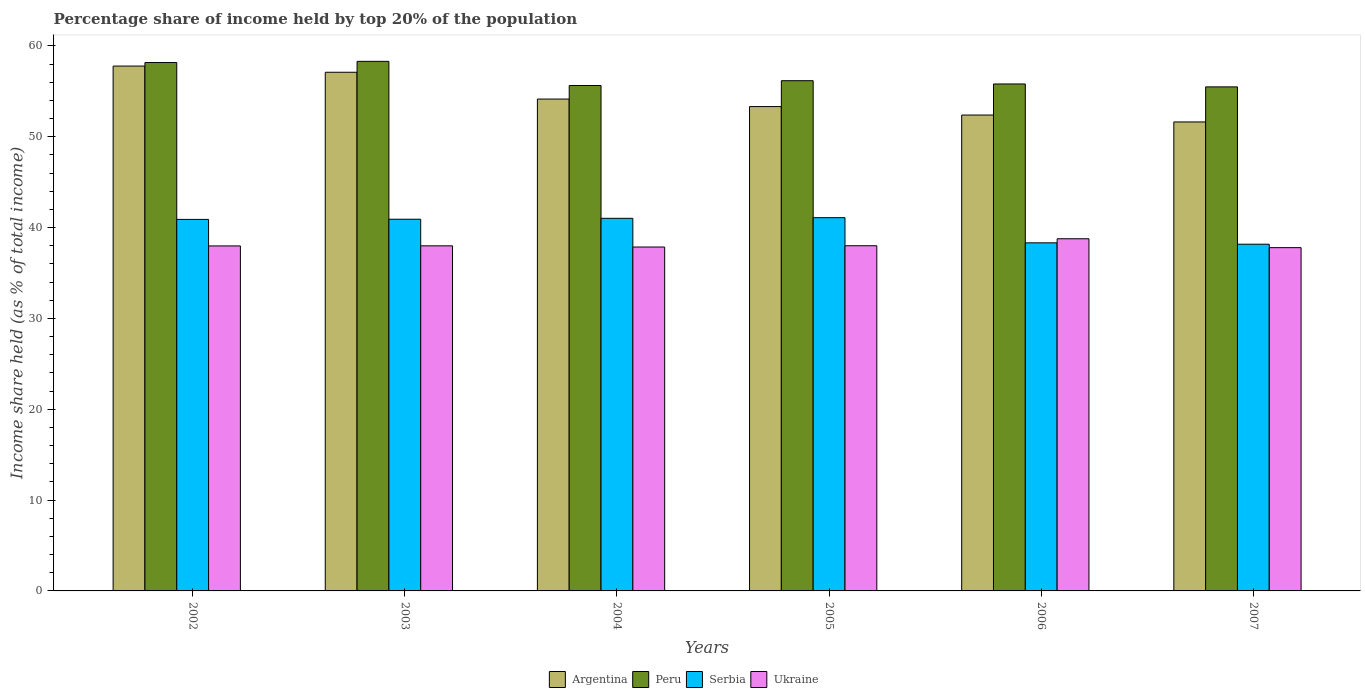How many different coloured bars are there?
Provide a succinct answer. 4. Are the number of bars on each tick of the X-axis equal?
Provide a short and direct response. Yes. How many bars are there on the 5th tick from the right?
Give a very brief answer. 4. What is the label of the 4th group of bars from the left?
Your answer should be compact. 2005. In how many cases, is the number of bars for a given year not equal to the number of legend labels?
Keep it short and to the point. 0. What is the percentage share of income held by top 20% of the population in Peru in 2006?
Make the answer very short. 55.81. Across all years, what is the maximum percentage share of income held by top 20% of the population in Ukraine?
Keep it short and to the point. 38.77. Across all years, what is the minimum percentage share of income held by top 20% of the population in Serbia?
Provide a succinct answer. 38.17. In which year was the percentage share of income held by top 20% of the population in Peru maximum?
Make the answer very short. 2003. In which year was the percentage share of income held by top 20% of the population in Serbia minimum?
Ensure brevity in your answer.  2007. What is the total percentage share of income held by top 20% of the population in Argentina in the graph?
Make the answer very short. 326.37. What is the difference between the percentage share of income held by top 20% of the population in Serbia in 2003 and that in 2005?
Your response must be concise. -0.17. What is the difference between the percentage share of income held by top 20% of the population in Serbia in 2005 and the percentage share of income held by top 20% of the population in Peru in 2004?
Provide a short and direct response. -14.55. What is the average percentage share of income held by top 20% of the population in Peru per year?
Give a very brief answer. 56.6. In the year 2006, what is the difference between the percentage share of income held by top 20% of the population in Serbia and percentage share of income held by top 20% of the population in Peru?
Your answer should be very brief. -17.49. What is the ratio of the percentage share of income held by top 20% of the population in Serbia in 2004 to that in 2007?
Provide a short and direct response. 1.07. Is the difference between the percentage share of income held by top 20% of the population in Serbia in 2002 and 2006 greater than the difference between the percentage share of income held by top 20% of the population in Peru in 2002 and 2006?
Provide a short and direct response. Yes. What is the difference between the highest and the second highest percentage share of income held by top 20% of the population in Argentina?
Offer a terse response. 0.68. What is the difference between the highest and the lowest percentage share of income held by top 20% of the population in Peru?
Ensure brevity in your answer.  2.81. In how many years, is the percentage share of income held by top 20% of the population in Serbia greater than the average percentage share of income held by top 20% of the population in Serbia taken over all years?
Keep it short and to the point. 4. Is the sum of the percentage share of income held by top 20% of the population in Ukraine in 2002 and 2005 greater than the maximum percentage share of income held by top 20% of the population in Argentina across all years?
Provide a short and direct response. Yes. What does the 2nd bar from the left in 2002 represents?
Your answer should be very brief. Peru. What does the 2nd bar from the right in 2007 represents?
Offer a terse response. Serbia. Is it the case that in every year, the sum of the percentage share of income held by top 20% of the population in Peru and percentage share of income held by top 20% of the population in Ukraine is greater than the percentage share of income held by top 20% of the population in Argentina?
Ensure brevity in your answer.  Yes. How many bars are there?
Your answer should be compact. 24. Are all the bars in the graph horizontal?
Give a very brief answer. No. Are the values on the major ticks of Y-axis written in scientific E-notation?
Offer a very short reply. No. What is the title of the graph?
Give a very brief answer. Percentage share of income held by top 20% of the population. What is the label or title of the Y-axis?
Provide a succinct answer. Income share held (as % of total income). What is the Income share held (as % of total income) of Argentina in 2002?
Your response must be concise. 57.78. What is the Income share held (as % of total income) in Peru in 2002?
Offer a very short reply. 58.17. What is the Income share held (as % of total income) in Serbia in 2002?
Your answer should be compact. 40.9. What is the Income share held (as % of total income) of Ukraine in 2002?
Provide a short and direct response. 37.98. What is the Income share held (as % of total income) in Argentina in 2003?
Make the answer very short. 57.1. What is the Income share held (as % of total income) of Peru in 2003?
Offer a very short reply. 58.3. What is the Income share held (as % of total income) in Serbia in 2003?
Make the answer very short. 40.92. What is the Income share held (as % of total income) in Ukraine in 2003?
Ensure brevity in your answer.  37.99. What is the Income share held (as % of total income) in Argentina in 2004?
Give a very brief answer. 54.15. What is the Income share held (as % of total income) of Peru in 2004?
Your answer should be compact. 55.64. What is the Income share held (as % of total income) in Serbia in 2004?
Your answer should be very brief. 41.02. What is the Income share held (as % of total income) of Ukraine in 2004?
Your answer should be compact. 37.86. What is the Income share held (as % of total income) in Argentina in 2005?
Offer a terse response. 53.32. What is the Income share held (as % of total income) of Peru in 2005?
Offer a very short reply. 56.17. What is the Income share held (as % of total income) in Serbia in 2005?
Give a very brief answer. 41.09. What is the Income share held (as % of total income) of Argentina in 2006?
Keep it short and to the point. 52.39. What is the Income share held (as % of total income) of Peru in 2006?
Offer a very short reply. 55.81. What is the Income share held (as % of total income) of Serbia in 2006?
Provide a short and direct response. 38.32. What is the Income share held (as % of total income) of Ukraine in 2006?
Make the answer very short. 38.77. What is the Income share held (as % of total income) of Argentina in 2007?
Offer a terse response. 51.63. What is the Income share held (as % of total income) of Peru in 2007?
Your answer should be compact. 55.49. What is the Income share held (as % of total income) of Serbia in 2007?
Offer a very short reply. 38.17. What is the Income share held (as % of total income) in Ukraine in 2007?
Your response must be concise. 37.79. Across all years, what is the maximum Income share held (as % of total income) of Argentina?
Provide a short and direct response. 57.78. Across all years, what is the maximum Income share held (as % of total income) of Peru?
Provide a short and direct response. 58.3. Across all years, what is the maximum Income share held (as % of total income) in Serbia?
Make the answer very short. 41.09. Across all years, what is the maximum Income share held (as % of total income) in Ukraine?
Offer a terse response. 38.77. Across all years, what is the minimum Income share held (as % of total income) in Argentina?
Offer a terse response. 51.63. Across all years, what is the minimum Income share held (as % of total income) of Peru?
Your answer should be compact. 55.49. Across all years, what is the minimum Income share held (as % of total income) in Serbia?
Your answer should be compact. 38.17. Across all years, what is the minimum Income share held (as % of total income) of Ukraine?
Ensure brevity in your answer.  37.79. What is the total Income share held (as % of total income) in Argentina in the graph?
Keep it short and to the point. 326.37. What is the total Income share held (as % of total income) in Peru in the graph?
Offer a very short reply. 339.58. What is the total Income share held (as % of total income) of Serbia in the graph?
Your answer should be very brief. 240.42. What is the total Income share held (as % of total income) of Ukraine in the graph?
Your answer should be very brief. 228.39. What is the difference between the Income share held (as % of total income) of Argentina in 2002 and that in 2003?
Offer a very short reply. 0.68. What is the difference between the Income share held (as % of total income) in Peru in 2002 and that in 2003?
Give a very brief answer. -0.13. What is the difference between the Income share held (as % of total income) in Serbia in 2002 and that in 2003?
Your response must be concise. -0.02. What is the difference between the Income share held (as % of total income) of Ukraine in 2002 and that in 2003?
Your answer should be compact. -0.01. What is the difference between the Income share held (as % of total income) in Argentina in 2002 and that in 2004?
Your answer should be very brief. 3.63. What is the difference between the Income share held (as % of total income) in Peru in 2002 and that in 2004?
Keep it short and to the point. 2.53. What is the difference between the Income share held (as % of total income) of Serbia in 2002 and that in 2004?
Provide a short and direct response. -0.12. What is the difference between the Income share held (as % of total income) in Ukraine in 2002 and that in 2004?
Offer a very short reply. 0.12. What is the difference between the Income share held (as % of total income) in Argentina in 2002 and that in 2005?
Give a very brief answer. 4.46. What is the difference between the Income share held (as % of total income) of Peru in 2002 and that in 2005?
Offer a terse response. 2. What is the difference between the Income share held (as % of total income) of Serbia in 2002 and that in 2005?
Your response must be concise. -0.19. What is the difference between the Income share held (as % of total income) of Ukraine in 2002 and that in 2005?
Your response must be concise. -0.02. What is the difference between the Income share held (as % of total income) in Argentina in 2002 and that in 2006?
Provide a short and direct response. 5.39. What is the difference between the Income share held (as % of total income) of Peru in 2002 and that in 2006?
Your response must be concise. 2.36. What is the difference between the Income share held (as % of total income) in Serbia in 2002 and that in 2006?
Offer a very short reply. 2.58. What is the difference between the Income share held (as % of total income) of Ukraine in 2002 and that in 2006?
Your answer should be compact. -0.79. What is the difference between the Income share held (as % of total income) in Argentina in 2002 and that in 2007?
Make the answer very short. 6.15. What is the difference between the Income share held (as % of total income) in Peru in 2002 and that in 2007?
Your answer should be compact. 2.68. What is the difference between the Income share held (as % of total income) in Serbia in 2002 and that in 2007?
Your response must be concise. 2.73. What is the difference between the Income share held (as % of total income) of Ukraine in 2002 and that in 2007?
Keep it short and to the point. 0.19. What is the difference between the Income share held (as % of total income) of Argentina in 2003 and that in 2004?
Keep it short and to the point. 2.95. What is the difference between the Income share held (as % of total income) of Peru in 2003 and that in 2004?
Offer a very short reply. 2.66. What is the difference between the Income share held (as % of total income) of Serbia in 2003 and that in 2004?
Your answer should be compact. -0.1. What is the difference between the Income share held (as % of total income) in Ukraine in 2003 and that in 2004?
Ensure brevity in your answer.  0.13. What is the difference between the Income share held (as % of total income) of Argentina in 2003 and that in 2005?
Make the answer very short. 3.78. What is the difference between the Income share held (as % of total income) in Peru in 2003 and that in 2005?
Provide a short and direct response. 2.13. What is the difference between the Income share held (as % of total income) in Serbia in 2003 and that in 2005?
Make the answer very short. -0.17. What is the difference between the Income share held (as % of total income) of Ukraine in 2003 and that in 2005?
Keep it short and to the point. -0.01. What is the difference between the Income share held (as % of total income) of Argentina in 2003 and that in 2006?
Give a very brief answer. 4.71. What is the difference between the Income share held (as % of total income) in Peru in 2003 and that in 2006?
Keep it short and to the point. 2.49. What is the difference between the Income share held (as % of total income) of Ukraine in 2003 and that in 2006?
Your answer should be very brief. -0.78. What is the difference between the Income share held (as % of total income) of Argentina in 2003 and that in 2007?
Provide a short and direct response. 5.47. What is the difference between the Income share held (as % of total income) in Peru in 2003 and that in 2007?
Offer a terse response. 2.81. What is the difference between the Income share held (as % of total income) of Serbia in 2003 and that in 2007?
Your answer should be compact. 2.75. What is the difference between the Income share held (as % of total income) in Ukraine in 2003 and that in 2007?
Provide a succinct answer. 0.2. What is the difference between the Income share held (as % of total income) of Argentina in 2004 and that in 2005?
Ensure brevity in your answer.  0.83. What is the difference between the Income share held (as % of total income) of Peru in 2004 and that in 2005?
Give a very brief answer. -0.53. What is the difference between the Income share held (as % of total income) in Serbia in 2004 and that in 2005?
Keep it short and to the point. -0.07. What is the difference between the Income share held (as % of total income) of Ukraine in 2004 and that in 2005?
Your answer should be compact. -0.14. What is the difference between the Income share held (as % of total income) in Argentina in 2004 and that in 2006?
Your answer should be very brief. 1.76. What is the difference between the Income share held (as % of total income) in Peru in 2004 and that in 2006?
Keep it short and to the point. -0.17. What is the difference between the Income share held (as % of total income) of Ukraine in 2004 and that in 2006?
Make the answer very short. -0.91. What is the difference between the Income share held (as % of total income) of Argentina in 2004 and that in 2007?
Provide a succinct answer. 2.52. What is the difference between the Income share held (as % of total income) in Peru in 2004 and that in 2007?
Ensure brevity in your answer.  0.15. What is the difference between the Income share held (as % of total income) of Serbia in 2004 and that in 2007?
Provide a short and direct response. 2.85. What is the difference between the Income share held (as % of total income) of Ukraine in 2004 and that in 2007?
Ensure brevity in your answer.  0.07. What is the difference between the Income share held (as % of total income) of Argentina in 2005 and that in 2006?
Provide a succinct answer. 0.93. What is the difference between the Income share held (as % of total income) of Peru in 2005 and that in 2006?
Your response must be concise. 0.36. What is the difference between the Income share held (as % of total income) of Serbia in 2005 and that in 2006?
Give a very brief answer. 2.77. What is the difference between the Income share held (as % of total income) in Ukraine in 2005 and that in 2006?
Your answer should be very brief. -0.77. What is the difference between the Income share held (as % of total income) of Argentina in 2005 and that in 2007?
Offer a terse response. 1.69. What is the difference between the Income share held (as % of total income) in Peru in 2005 and that in 2007?
Your response must be concise. 0.68. What is the difference between the Income share held (as % of total income) in Serbia in 2005 and that in 2007?
Ensure brevity in your answer.  2.92. What is the difference between the Income share held (as % of total income) in Ukraine in 2005 and that in 2007?
Ensure brevity in your answer.  0.21. What is the difference between the Income share held (as % of total income) of Argentina in 2006 and that in 2007?
Provide a short and direct response. 0.76. What is the difference between the Income share held (as % of total income) in Peru in 2006 and that in 2007?
Provide a short and direct response. 0.32. What is the difference between the Income share held (as % of total income) of Serbia in 2006 and that in 2007?
Your answer should be very brief. 0.15. What is the difference between the Income share held (as % of total income) in Argentina in 2002 and the Income share held (as % of total income) in Peru in 2003?
Make the answer very short. -0.52. What is the difference between the Income share held (as % of total income) of Argentina in 2002 and the Income share held (as % of total income) of Serbia in 2003?
Your response must be concise. 16.86. What is the difference between the Income share held (as % of total income) of Argentina in 2002 and the Income share held (as % of total income) of Ukraine in 2003?
Your answer should be very brief. 19.79. What is the difference between the Income share held (as % of total income) in Peru in 2002 and the Income share held (as % of total income) in Serbia in 2003?
Keep it short and to the point. 17.25. What is the difference between the Income share held (as % of total income) in Peru in 2002 and the Income share held (as % of total income) in Ukraine in 2003?
Offer a terse response. 20.18. What is the difference between the Income share held (as % of total income) of Serbia in 2002 and the Income share held (as % of total income) of Ukraine in 2003?
Your answer should be compact. 2.91. What is the difference between the Income share held (as % of total income) in Argentina in 2002 and the Income share held (as % of total income) in Peru in 2004?
Provide a succinct answer. 2.14. What is the difference between the Income share held (as % of total income) in Argentina in 2002 and the Income share held (as % of total income) in Serbia in 2004?
Ensure brevity in your answer.  16.76. What is the difference between the Income share held (as % of total income) in Argentina in 2002 and the Income share held (as % of total income) in Ukraine in 2004?
Offer a very short reply. 19.92. What is the difference between the Income share held (as % of total income) of Peru in 2002 and the Income share held (as % of total income) of Serbia in 2004?
Your response must be concise. 17.15. What is the difference between the Income share held (as % of total income) of Peru in 2002 and the Income share held (as % of total income) of Ukraine in 2004?
Make the answer very short. 20.31. What is the difference between the Income share held (as % of total income) of Serbia in 2002 and the Income share held (as % of total income) of Ukraine in 2004?
Keep it short and to the point. 3.04. What is the difference between the Income share held (as % of total income) of Argentina in 2002 and the Income share held (as % of total income) of Peru in 2005?
Provide a short and direct response. 1.61. What is the difference between the Income share held (as % of total income) in Argentina in 2002 and the Income share held (as % of total income) in Serbia in 2005?
Provide a short and direct response. 16.69. What is the difference between the Income share held (as % of total income) of Argentina in 2002 and the Income share held (as % of total income) of Ukraine in 2005?
Offer a very short reply. 19.78. What is the difference between the Income share held (as % of total income) of Peru in 2002 and the Income share held (as % of total income) of Serbia in 2005?
Provide a succinct answer. 17.08. What is the difference between the Income share held (as % of total income) of Peru in 2002 and the Income share held (as % of total income) of Ukraine in 2005?
Offer a very short reply. 20.17. What is the difference between the Income share held (as % of total income) of Argentina in 2002 and the Income share held (as % of total income) of Peru in 2006?
Provide a succinct answer. 1.97. What is the difference between the Income share held (as % of total income) in Argentina in 2002 and the Income share held (as % of total income) in Serbia in 2006?
Provide a succinct answer. 19.46. What is the difference between the Income share held (as % of total income) of Argentina in 2002 and the Income share held (as % of total income) of Ukraine in 2006?
Your answer should be compact. 19.01. What is the difference between the Income share held (as % of total income) in Peru in 2002 and the Income share held (as % of total income) in Serbia in 2006?
Offer a terse response. 19.85. What is the difference between the Income share held (as % of total income) in Serbia in 2002 and the Income share held (as % of total income) in Ukraine in 2006?
Give a very brief answer. 2.13. What is the difference between the Income share held (as % of total income) of Argentina in 2002 and the Income share held (as % of total income) of Peru in 2007?
Your response must be concise. 2.29. What is the difference between the Income share held (as % of total income) in Argentina in 2002 and the Income share held (as % of total income) in Serbia in 2007?
Provide a succinct answer. 19.61. What is the difference between the Income share held (as % of total income) of Argentina in 2002 and the Income share held (as % of total income) of Ukraine in 2007?
Offer a terse response. 19.99. What is the difference between the Income share held (as % of total income) of Peru in 2002 and the Income share held (as % of total income) of Ukraine in 2007?
Provide a succinct answer. 20.38. What is the difference between the Income share held (as % of total income) of Serbia in 2002 and the Income share held (as % of total income) of Ukraine in 2007?
Offer a terse response. 3.11. What is the difference between the Income share held (as % of total income) in Argentina in 2003 and the Income share held (as % of total income) in Peru in 2004?
Keep it short and to the point. 1.46. What is the difference between the Income share held (as % of total income) in Argentina in 2003 and the Income share held (as % of total income) in Serbia in 2004?
Provide a short and direct response. 16.08. What is the difference between the Income share held (as % of total income) of Argentina in 2003 and the Income share held (as % of total income) of Ukraine in 2004?
Provide a short and direct response. 19.24. What is the difference between the Income share held (as % of total income) in Peru in 2003 and the Income share held (as % of total income) in Serbia in 2004?
Offer a very short reply. 17.28. What is the difference between the Income share held (as % of total income) in Peru in 2003 and the Income share held (as % of total income) in Ukraine in 2004?
Offer a very short reply. 20.44. What is the difference between the Income share held (as % of total income) of Serbia in 2003 and the Income share held (as % of total income) of Ukraine in 2004?
Give a very brief answer. 3.06. What is the difference between the Income share held (as % of total income) in Argentina in 2003 and the Income share held (as % of total income) in Peru in 2005?
Your answer should be compact. 0.93. What is the difference between the Income share held (as % of total income) of Argentina in 2003 and the Income share held (as % of total income) of Serbia in 2005?
Give a very brief answer. 16.01. What is the difference between the Income share held (as % of total income) of Peru in 2003 and the Income share held (as % of total income) of Serbia in 2005?
Provide a succinct answer. 17.21. What is the difference between the Income share held (as % of total income) of Peru in 2003 and the Income share held (as % of total income) of Ukraine in 2005?
Offer a terse response. 20.3. What is the difference between the Income share held (as % of total income) in Serbia in 2003 and the Income share held (as % of total income) in Ukraine in 2005?
Your answer should be compact. 2.92. What is the difference between the Income share held (as % of total income) in Argentina in 2003 and the Income share held (as % of total income) in Peru in 2006?
Ensure brevity in your answer.  1.29. What is the difference between the Income share held (as % of total income) of Argentina in 2003 and the Income share held (as % of total income) of Serbia in 2006?
Ensure brevity in your answer.  18.78. What is the difference between the Income share held (as % of total income) in Argentina in 2003 and the Income share held (as % of total income) in Ukraine in 2006?
Keep it short and to the point. 18.33. What is the difference between the Income share held (as % of total income) in Peru in 2003 and the Income share held (as % of total income) in Serbia in 2006?
Give a very brief answer. 19.98. What is the difference between the Income share held (as % of total income) of Peru in 2003 and the Income share held (as % of total income) of Ukraine in 2006?
Your answer should be very brief. 19.53. What is the difference between the Income share held (as % of total income) of Serbia in 2003 and the Income share held (as % of total income) of Ukraine in 2006?
Offer a very short reply. 2.15. What is the difference between the Income share held (as % of total income) of Argentina in 2003 and the Income share held (as % of total income) of Peru in 2007?
Your answer should be compact. 1.61. What is the difference between the Income share held (as % of total income) of Argentina in 2003 and the Income share held (as % of total income) of Serbia in 2007?
Your response must be concise. 18.93. What is the difference between the Income share held (as % of total income) in Argentina in 2003 and the Income share held (as % of total income) in Ukraine in 2007?
Provide a succinct answer. 19.31. What is the difference between the Income share held (as % of total income) of Peru in 2003 and the Income share held (as % of total income) of Serbia in 2007?
Ensure brevity in your answer.  20.13. What is the difference between the Income share held (as % of total income) of Peru in 2003 and the Income share held (as % of total income) of Ukraine in 2007?
Give a very brief answer. 20.51. What is the difference between the Income share held (as % of total income) in Serbia in 2003 and the Income share held (as % of total income) in Ukraine in 2007?
Provide a succinct answer. 3.13. What is the difference between the Income share held (as % of total income) in Argentina in 2004 and the Income share held (as % of total income) in Peru in 2005?
Ensure brevity in your answer.  -2.02. What is the difference between the Income share held (as % of total income) in Argentina in 2004 and the Income share held (as % of total income) in Serbia in 2005?
Give a very brief answer. 13.06. What is the difference between the Income share held (as % of total income) of Argentina in 2004 and the Income share held (as % of total income) of Ukraine in 2005?
Provide a succinct answer. 16.15. What is the difference between the Income share held (as % of total income) in Peru in 2004 and the Income share held (as % of total income) in Serbia in 2005?
Provide a succinct answer. 14.55. What is the difference between the Income share held (as % of total income) of Peru in 2004 and the Income share held (as % of total income) of Ukraine in 2005?
Ensure brevity in your answer.  17.64. What is the difference between the Income share held (as % of total income) of Serbia in 2004 and the Income share held (as % of total income) of Ukraine in 2005?
Offer a terse response. 3.02. What is the difference between the Income share held (as % of total income) of Argentina in 2004 and the Income share held (as % of total income) of Peru in 2006?
Provide a succinct answer. -1.66. What is the difference between the Income share held (as % of total income) of Argentina in 2004 and the Income share held (as % of total income) of Serbia in 2006?
Your answer should be compact. 15.83. What is the difference between the Income share held (as % of total income) of Argentina in 2004 and the Income share held (as % of total income) of Ukraine in 2006?
Make the answer very short. 15.38. What is the difference between the Income share held (as % of total income) in Peru in 2004 and the Income share held (as % of total income) in Serbia in 2006?
Keep it short and to the point. 17.32. What is the difference between the Income share held (as % of total income) of Peru in 2004 and the Income share held (as % of total income) of Ukraine in 2006?
Your answer should be compact. 16.87. What is the difference between the Income share held (as % of total income) of Serbia in 2004 and the Income share held (as % of total income) of Ukraine in 2006?
Offer a very short reply. 2.25. What is the difference between the Income share held (as % of total income) of Argentina in 2004 and the Income share held (as % of total income) of Peru in 2007?
Offer a very short reply. -1.34. What is the difference between the Income share held (as % of total income) in Argentina in 2004 and the Income share held (as % of total income) in Serbia in 2007?
Keep it short and to the point. 15.98. What is the difference between the Income share held (as % of total income) in Argentina in 2004 and the Income share held (as % of total income) in Ukraine in 2007?
Your answer should be very brief. 16.36. What is the difference between the Income share held (as % of total income) in Peru in 2004 and the Income share held (as % of total income) in Serbia in 2007?
Your response must be concise. 17.47. What is the difference between the Income share held (as % of total income) of Peru in 2004 and the Income share held (as % of total income) of Ukraine in 2007?
Give a very brief answer. 17.85. What is the difference between the Income share held (as % of total income) of Serbia in 2004 and the Income share held (as % of total income) of Ukraine in 2007?
Offer a terse response. 3.23. What is the difference between the Income share held (as % of total income) in Argentina in 2005 and the Income share held (as % of total income) in Peru in 2006?
Ensure brevity in your answer.  -2.49. What is the difference between the Income share held (as % of total income) of Argentina in 2005 and the Income share held (as % of total income) of Serbia in 2006?
Give a very brief answer. 15. What is the difference between the Income share held (as % of total income) of Argentina in 2005 and the Income share held (as % of total income) of Ukraine in 2006?
Your answer should be compact. 14.55. What is the difference between the Income share held (as % of total income) in Peru in 2005 and the Income share held (as % of total income) in Serbia in 2006?
Your answer should be very brief. 17.85. What is the difference between the Income share held (as % of total income) of Peru in 2005 and the Income share held (as % of total income) of Ukraine in 2006?
Offer a terse response. 17.4. What is the difference between the Income share held (as % of total income) in Serbia in 2005 and the Income share held (as % of total income) in Ukraine in 2006?
Keep it short and to the point. 2.32. What is the difference between the Income share held (as % of total income) in Argentina in 2005 and the Income share held (as % of total income) in Peru in 2007?
Your response must be concise. -2.17. What is the difference between the Income share held (as % of total income) of Argentina in 2005 and the Income share held (as % of total income) of Serbia in 2007?
Offer a terse response. 15.15. What is the difference between the Income share held (as % of total income) of Argentina in 2005 and the Income share held (as % of total income) of Ukraine in 2007?
Your answer should be very brief. 15.53. What is the difference between the Income share held (as % of total income) in Peru in 2005 and the Income share held (as % of total income) in Ukraine in 2007?
Provide a short and direct response. 18.38. What is the difference between the Income share held (as % of total income) in Serbia in 2005 and the Income share held (as % of total income) in Ukraine in 2007?
Provide a short and direct response. 3.3. What is the difference between the Income share held (as % of total income) of Argentina in 2006 and the Income share held (as % of total income) of Serbia in 2007?
Offer a terse response. 14.22. What is the difference between the Income share held (as % of total income) of Peru in 2006 and the Income share held (as % of total income) of Serbia in 2007?
Make the answer very short. 17.64. What is the difference between the Income share held (as % of total income) in Peru in 2006 and the Income share held (as % of total income) in Ukraine in 2007?
Give a very brief answer. 18.02. What is the difference between the Income share held (as % of total income) in Serbia in 2006 and the Income share held (as % of total income) in Ukraine in 2007?
Offer a terse response. 0.53. What is the average Income share held (as % of total income) in Argentina per year?
Give a very brief answer. 54.4. What is the average Income share held (as % of total income) of Peru per year?
Your response must be concise. 56.6. What is the average Income share held (as % of total income) in Serbia per year?
Make the answer very short. 40.07. What is the average Income share held (as % of total income) in Ukraine per year?
Your response must be concise. 38.06. In the year 2002, what is the difference between the Income share held (as % of total income) of Argentina and Income share held (as % of total income) of Peru?
Offer a very short reply. -0.39. In the year 2002, what is the difference between the Income share held (as % of total income) of Argentina and Income share held (as % of total income) of Serbia?
Give a very brief answer. 16.88. In the year 2002, what is the difference between the Income share held (as % of total income) of Argentina and Income share held (as % of total income) of Ukraine?
Ensure brevity in your answer.  19.8. In the year 2002, what is the difference between the Income share held (as % of total income) of Peru and Income share held (as % of total income) of Serbia?
Provide a short and direct response. 17.27. In the year 2002, what is the difference between the Income share held (as % of total income) in Peru and Income share held (as % of total income) in Ukraine?
Ensure brevity in your answer.  20.19. In the year 2002, what is the difference between the Income share held (as % of total income) of Serbia and Income share held (as % of total income) of Ukraine?
Your answer should be compact. 2.92. In the year 2003, what is the difference between the Income share held (as % of total income) of Argentina and Income share held (as % of total income) of Peru?
Offer a terse response. -1.2. In the year 2003, what is the difference between the Income share held (as % of total income) of Argentina and Income share held (as % of total income) of Serbia?
Provide a short and direct response. 16.18. In the year 2003, what is the difference between the Income share held (as % of total income) in Argentina and Income share held (as % of total income) in Ukraine?
Provide a succinct answer. 19.11. In the year 2003, what is the difference between the Income share held (as % of total income) in Peru and Income share held (as % of total income) in Serbia?
Ensure brevity in your answer.  17.38. In the year 2003, what is the difference between the Income share held (as % of total income) in Peru and Income share held (as % of total income) in Ukraine?
Ensure brevity in your answer.  20.31. In the year 2003, what is the difference between the Income share held (as % of total income) of Serbia and Income share held (as % of total income) of Ukraine?
Your answer should be compact. 2.93. In the year 2004, what is the difference between the Income share held (as % of total income) of Argentina and Income share held (as % of total income) of Peru?
Ensure brevity in your answer.  -1.49. In the year 2004, what is the difference between the Income share held (as % of total income) of Argentina and Income share held (as % of total income) of Serbia?
Provide a succinct answer. 13.13. In the year 2004, what is the difference between the Income share held (as % of total income) of Argentina and Income share held (as % of total income) of Ukraine?
Make the answer very short. 16.29. In the year 2004, what is the difference between the Income share held (as % of total income) in Peru and Income share held (as % of total income) in Serbia?
Provide a succinct answer. 14.62. In the year 2004, what is the difference between the Income share held (as % of total income) in Peru and Income share held (as % of total income) in Ukraine?
Offer a terse response. 17.78. In the year 2004, what is the difference between the Income share held (as % of total income) of Serbia and Income share held (as % of total income) of Ukraine?
Provide a short and direct response. 3.16. In the year 2005, what is the difference between the Income share held (as % of total income) of Argentina and Income share held (as % of total income) of Peru?
Your answer should be compact. -2.85. In the year 2005, what is the difference between the Income share held (as % of total income) of Argentina and Income share held (as % of total income) of Serbia?
Provide a short and direct response. 12.23. In the year 2005, what is the difference between the Income share held (as % of total income) in Argentina and Income share held (as % of total income) in Ukraine?
Your answer should be compact. 15.32. In the year 2005, what is the difference between the Income share held (as % of total income) of Peru and Income share held (as % of total income) of Serbia?
Ensure brevity in your answer.  15.08. In the year 2005, what is the difference between the Income share held (as % of total income) of Peru and Income share held (as % of total income) of Ukraine?
Keep it short and to the point. 18.17. In the year 2005, what is the difference between the Income share held (as % of total income) of Serbia and Income share held (as % of total income) of Ukraine?
Provide a succinct answer. 3.09. In the year 2006, what is the difference between the Income share held (as % of total income) in Argentina and Income share held (as % of total income) in Peru?
Your answer should be compact. -3.42. In the year 2006, what is the difference between the Income share held (as % of total income) of Argentina and Income share held (as % of total income) of Serbia?
Make the answer very short. 14.07. In the year 2006, what is the difference between the Income share held (as % of total income) in Argentina and Income share held (as % of total income) in Ukraine?
Keep it short and to the point. 13.62. In the year 2006, what is the difference between the Income share held (as % of total income) of Peru and Income share held (as % of total income) of Serbia?
Your answer should be compact. 17.49. In the year 2006, what is the difference between the Income share held (as % of total income) of Peru and Income share held (as % of total income) of Ukraine?
Your answer should be very brief. 17.04. In the year 2006, what is the difference between the Income share held (as % of total income) of Serbia and Income share held (as % of total income) of Ukraine?
Your answer should be compact. -0.45. In the year 2007, what is the difference between the Income share held (as % of total income) in Argentina and Income share held (as % of total income) in Peru?
Make the answer very short. -3.86. In the year 2007, what is the difference between the Income share held (as % of total income) of Argentina and Income share held (as % of total income) of Serbia?
Provide a succinct answer. 13.46. In the year 2007, what is the difference between the Income share held (as % of total income) in Argentina and Income share held (as % of total income) in Ukraine?
Your response must be concise. 13.84. In the year 2007, what is the difference between the Income share held (as % of total income) of Peru and Income share held (as % of total income) of Serbia?
Your answer should be very brief. 17.32. In the year 2007, what is the difference between the Income share held (as % of total income) of Serbia and Income share held (as % of total income) of Ukraine?
Make the answer very short. 0.38. What is the ratio of the Income share held (as % of total income) in Argentina in 2002 to that in 2003?
Give a very brief answer. 1.01. What is the ratio of the Income share held (as % of total income) in Peru in 2002 to that in 2003?
Offer a terse response. 1. What is the ratio of the Income share held (as % of total income) of Argentina in 2002 to that in 2004?
Your answer should be compact. 1.07. What is the ratio of the Income share held (as % of total income) in Peru in 2002 to that in 2004?
Make the answer very short. 1.05. What is the ratio of the Income share held (as % of total income) of Ukraine in 2002 to that in 2004?
Your response must be concise. 1. What is the ratio of the Income share held (as % of total income) in Argentina in 2002 to that in 2005?
Make the answer very short. 1.08. What is the ratio of the Income share held (as % of total income) in Peru in 2002 to that in 2005?
Your answer should be compact. 1.04. What is the ratio of the Income share held (as % of total income) in Ukraine in 2002 to that in 2005?
Keep it short and to the point. 1. What is the ratio of the Income share held (as % of total income) of Argentina in 2002 to that in 2006?
Provide a succinct answer. 1.1. What is the ratio of the Income share held (as % of total income) of Peru in 2002 to that in 2006?
Offer a very short reply. 1.04. What is the ratio of the Income share held (as % of total income) of Serbia in 2002 to that in 2006?
Offer a terse response. 1.07. What is the ratio of the Income share held (as % of total income) in Ukraine in 2002 to that in 2006?
Keep it short and to the point. 0.98. What is the ratio of the Income share held (as % of total income) in Argentina in 2002 to that in 2007?
Keep it short and to the point. 1.12. What is the ratio of the Income share held (as % of total income) of Peru in 2002 to that in 2007?
Make the answer very short. 1.05. What is the ratio of the Income share held (as % of total income) of Serbia in 2002 to that in 2007?
Provide a short and direct response. 1.07. What is the ratio of the Income share held (as % of total income) of Argentina in 2003 to that in 2004?
Give a very brief answer. 1.05. What is the ratio of the Income share held (as % of total income) in Peru in 2003 to that in 2004?
Give a very brief answer. 1.05. What is the ratio of the Income share held (as % of total income) in Serbia in 2003 to that in 2004?
Provide a succinct answer. 1. What is the ratio of the Income share held (as % of total income) in Argentina in 2003 to that in 2005?
Your answer should be very brief. 1.07. What is the ratio of the Income share held (as % of total income) of Peru in 2003 to that in 2005?
Keep it short and to the point. 1.04. What is the ratio of the Income share held (as % of total income) in Argentina in 2003 to that in 2006?
Your answer should be very brief. 1.09. What is the ratio of the Income share held (as % of total income) in Peru in 2003 to that in 2006?
Offer a very short reply. 1.04. What is the ratio of the Income share held (as % of total income) in Serbia in 2003 to that in 2006?
Provide a succinct answer. 1.07. What is the ratio of the Income share held (as % of total income) in Ukraine in 2003 to that in 2006?
Offer a terse response. 0.98. What is the ratio of the Income share held (as % of total income) of Argentina in 2003 to that in 2007?
Your response must be concise. 1.11. What is the ratio of the Income share held (as % of total income) of Peru in 2003 to that in 2007?
Offer a very short reply. 1.05. What is the ratio of the Income share held (as % of total income) of Serbia in 2003 to that in 2007?
Provide a succinct answer. 1.07. What is the ratio of the Income share held (as % of total income) in Argentina in 2004 to that in 2005?
Your answer should be very brief. 1.02. What is the ratio of the Income share held (as % of total income) in Peru in 2004 to that in 2005?
Give a very brief answer. 0.99. What is the ratio of the Income share held (as % of total income) of Ukraine in 2004 to that in 2005?
Ensure brevity in your answer.  1. What is the ratio of the Income share held (as % of total income) in Argentina in 2004 to that in 2006?
Give a very brief answer. 1.03. What is the ratio of the Income share held (as % of total income) in Peru in 2004 to that in 2006?
Provide a short and direct response. 1. What is the ratio of the Income share held (as % of total income) of Serbia in 2004 to that in 2006?
Keep it short and to the point. 1.07. What is the ratio of the Income share held (as % of total income) of Ukraine in 2004 to that in 2006?
Your response must be concise. 0.98. What is the ratio of the Income share held (as % of total income) of Argentina in 2004 to that in 2007?
Ensure brevity in your answer.  1.05. What is the ratio of the Income share held (as % of total income) of Peru in 2004 to that in 2007?
Your response must be concise. 1. What is the ratio of the Income share held (as % of total income) of Serbia in 2004 to that in 2007?
Provide a short and direct response. 1.07. What is the ratio of the Income share held (as % of total income) of Ukraine in 2004 to that in 2007?
Make the answer very short. 1. What is the ratio of the Income share held (as % of total income) in Argentina in 2005 to that in 2006?
Your answer should be compact. 1.02. What is the ratio of the Income share held (as % of total income) in Peru in 2005 to that in 2006?
Offer a terse response. 1.01. What is the ratio of the Income share held (as % of total income) in Serbia in 2005 to that in 2006?
Your answer should be compact. 1.07. What is the ratio of the Income share held (as % of total income) in Ukraine in 2005 to that in 2006?
Keep it short and to the point. 0.98. What is the ratio of the Income share held (as % of total income) in Argentina in 2005 to that in 2007?
Make the answer very short. 1.03. What is the ratio of the Income share held (as % of total income) in Peru in 2005 to that in 2007?
Your answer should be compact. 1.01. What is the ratio of the Income share held (as % of total income) in Serbia in 2005 to that in 2007?
Your answer should be very brief. 1.08. What is the ratio of the Income share held (as % of total income) in Ukraine in 2005 to that in 2007?
Your answer should be compact. 1.01. What is the ratio of the Income share held (as % of total income) in Argentina in 2006 to that in 2007?
Provide a short and direct response. 1.01. What is the ratio of the Income share held (as % of total income) of Peru in 2006 to that in 2007?
Give a very brief answer. 1.01. What is the ratio of the Income share held (as % of total income) of Ukraine in 2006 to that in 2007?
Give a very brief answer. 1.03. What is the difference between the highest and the second highest Income share held (as % of total income) in Argentina?
Offer a very short reply. 0.68. What is the difference between the highest and the second highest Income share held (as % of total income) of Peru?
Offer a very short reply. 0.13. What is the difference between the highest and the second highest Income share held (as % of total income) in Serbia?
Your response must be concise. 0.07. What is the difference between the highest and the second highest Income share held (as % of total income) in Ukraine?
Your answer should be compact. 0.77. What is the difference between the highest and the lowest Income share held (as % of total income) of Argentina?
Offer a terse response. 6.15. What is the difference between the highest and the lowest Income share held (as % of total income) of Peru?
Your response must be concise. 2.81. What is the difference between the highest and the lowest Income share held (as % of total income) in Serbia?
Ensure brevity in your answer.  2.92. What is the difference between the highest and the lowest Income share held (as % of total income) of Ukraine?
Offer a terse response. 0.98. 